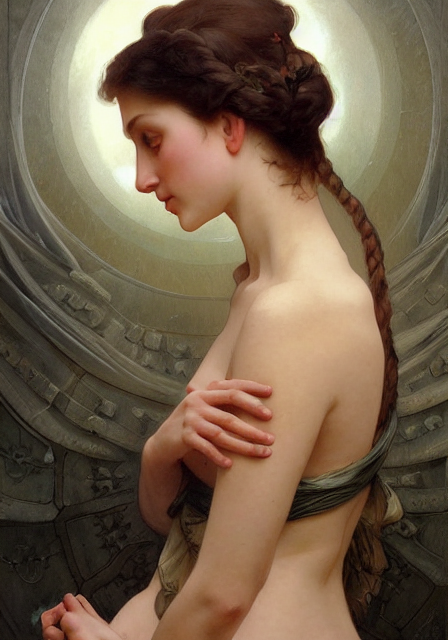Can you describe the artistic style used in this image? This image is painted in a neoclassical style, characterized by its lifelike representation, smooth brushwork, and the use of soft, diffused lighting to highlight the subject's delicate features and the graceful drapery. 